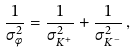<formula> <loc_0><loc_0><loc_500><loc_500>\frac { 1 } { \sigma ^ { 2 } _ { \phi } } = \frac { 1 } { \sigma ^ { 2 } _ { K ^ { + } } } + \frac { 1 } { \sigma ^ { 2 } _ { K ^ { - } } } \, ,</formula> 